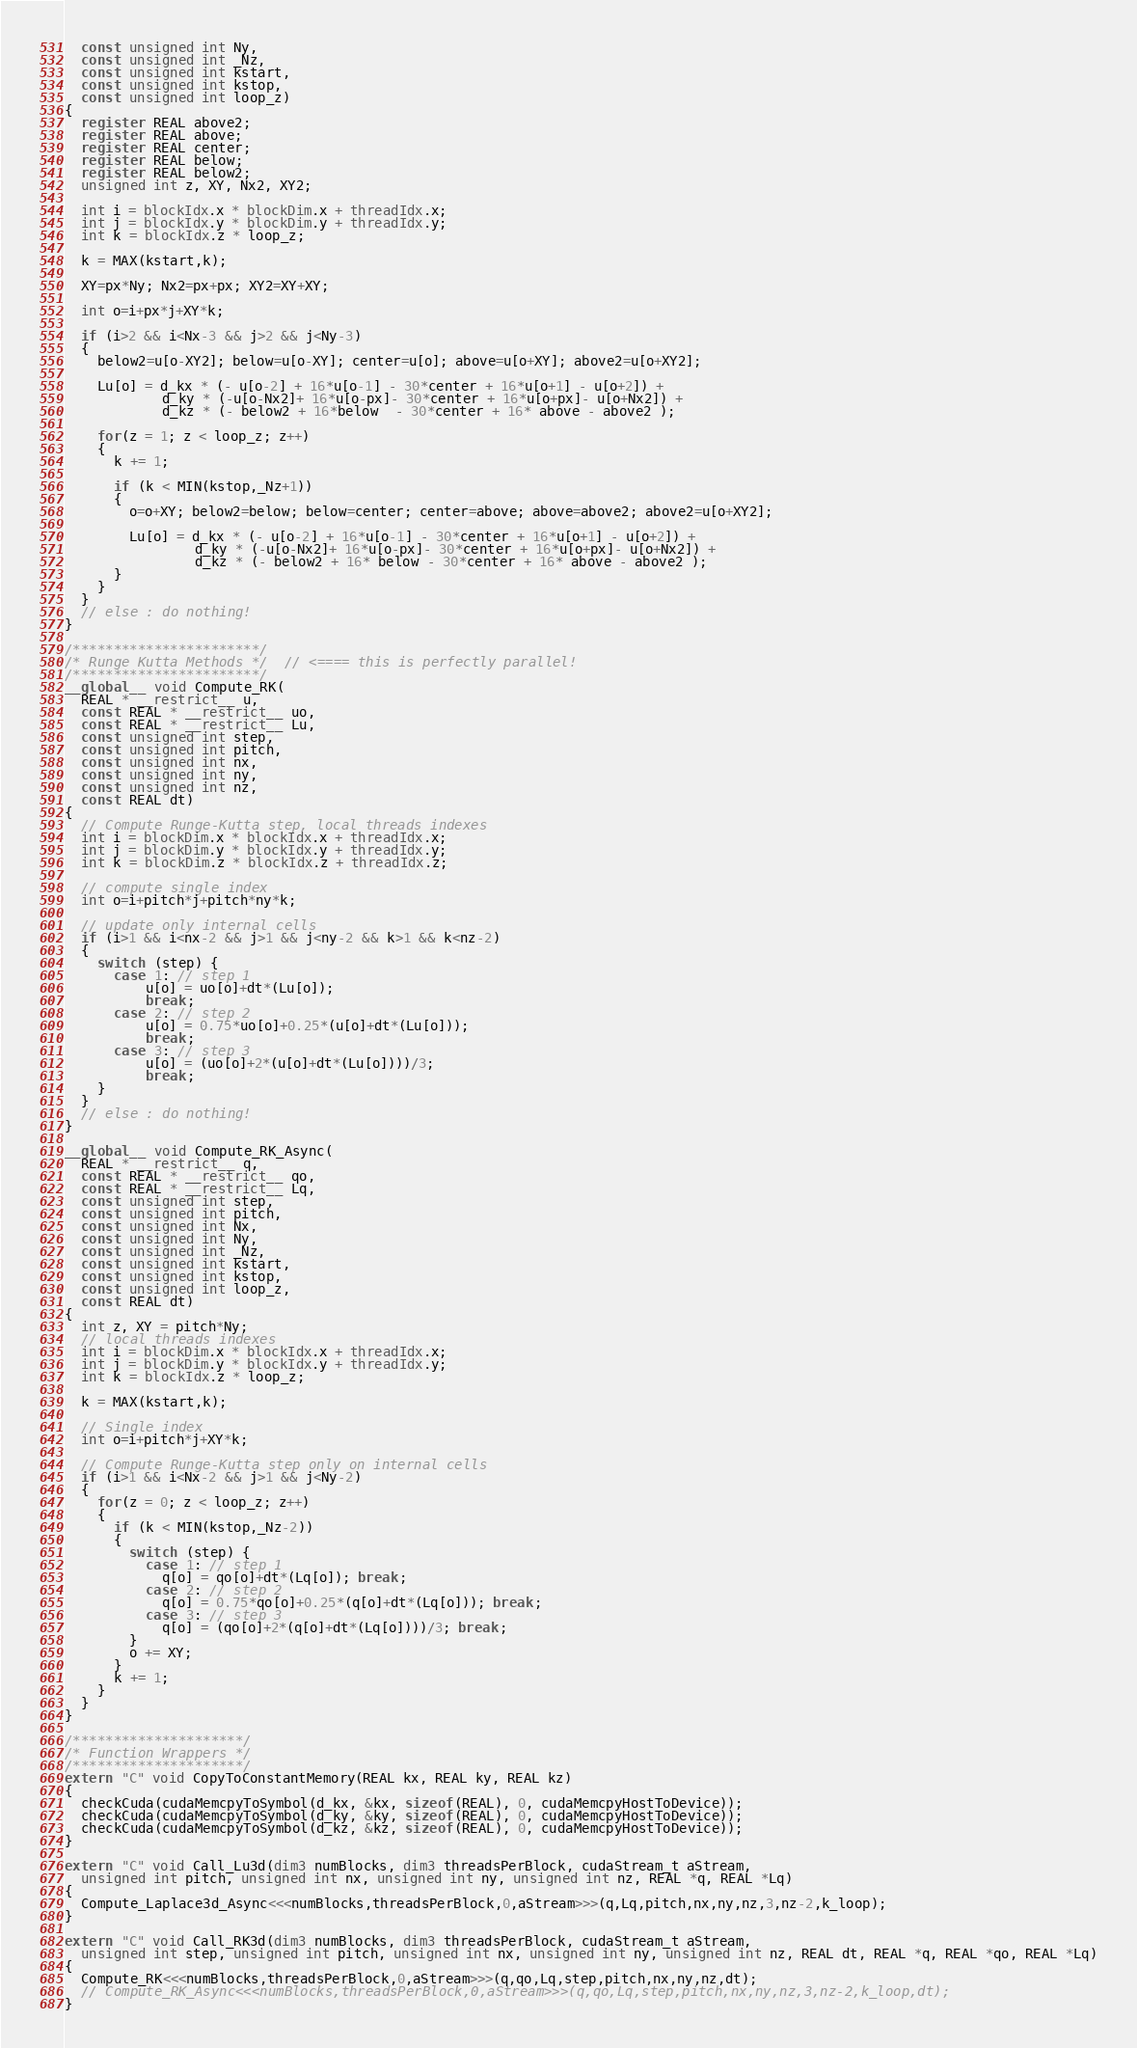Convert code to text. <code><loc_0><loc_0><loc_500><loc_500><_Cuda_>  const unsigned int Ny, 
  const unsigned int _Nz, 
  const unsigned int kstart, 
  const unsigned int kstop, 
  const unsigned int loop_z)
{
  register REAL above2;
  register REAL above;
  register REAL center;
  register REAL below;
  register REAL below2;
  unsigned int z, XY, Nx2, XY2;

  int i = blockIdx.x * blockDim.x + threadIdx.x;
  int j = blockIdx.y * blockDim.y + threadIdx.y;
  int k = blockIdx.z * loop_z;

  k = MAX(kstart,k);

  XY=px*Ny; Nx2=px+px; XY2=XY+XY; 

  int o=i+px*j+XY*k;

  if (i>2 && i<Nx-3 && j>2 && j<Ny-3)
  {
    below2=u[o-XY2]; below=u[o-XY]; center=u[o]; above=u[o+XY]; above2=u[o+XY2];

    Lu[o] = d_kx * (- u[o-2] + 16*u[o-1] - 30*center + 16*u[o+1] - u[o+2]) + 
            d_ky * (-u[o-Nx2]+ 16*u[o-px]- 30*center + 16*u[o+px]- u[o+Nx2]) +
            d_kz * (- below2 + 16*below  - 30*center + 16* above - above2 );

    for(z = 1; z < loop_z; z++)
    {
      k += 1;

      if (k < MIN(kstop,_Nz+1))
      {
        o=o+XY; below2=below; below=center; center=above; above=above2; above2=u[o+XY2];

        Lu[o] = d_kx * (- u[o-2] + 16*u[o-1] - 30*center + 16*u[o+1] - u[o+2]) +
                d_ky * (-u[o-Nx2]+ 16*u[o-px]- 30*center + 16*u[o+px]- u[o+Nx2]) +
                d_kz * (- below2 + 16* below - 30*center + 16* above - above2 );
      }
    }
  }
  // else : do nothing!
}

/***********************/
/* Runge Kutta Methods */  // <==== this is perfectly parallel!
/***********************/
__global__ void Compute_RK( 
  REAL * __restrict__ u, 
  const REAL * __restrict__ uo, 
  const REAL * __restrict__ Lu, 
  const unsigned int step, 
  const unsigned int pitch,
  const unsigned int nx, 
  const unsigned int ny, 
  const unsigned int nz, 
  const REAL dt)
{
  // Compute Runge-Kutta step, local threads indexes
  int i = blockDim.x * blockIdx.x + threadIdx.x;
  int j = blockDim.y * blockIdx.y + threadIdx.y;
  int k = blockDim.z * blockIdx.z + threadIdx.z;
    
  // compute single index
  int o=i+pitch*j+pitch*ny*k;

  // update only internal cells
  if (i>1 && i<nx-2 && j>1 && j<ny-2 && k>1 && k<nz-2)
  {
    switch (step) {
      case 1: // step 1
          u[o] = uo[o]+dt*(Lu[o]);
          break;
      case 2: // step 2
          u[o] = 0.75*uo[o]+0.25*(u[o]+dt*(Lu[o]));
          break;
      case 3: // step 3
          u[o] = (uo[o]+2*(u[o]+dt*(Lu[o])))/3;
          break;
    }
  }
  // else : do nothing!
}

__global__ void Compute_RK_Async( 
  REAL * __restrict__ q, 
  const REAL * __restrict__ qo, 
  const REAL * __restrict__ Lq, 
  const unsigned int step,
  const unsigned int pitch, 
  const unsigned int Nx, 
  const unsigned int Ny, 
  const unsigned int _Nz, 
  const unsigned int kstart, 
  const unsigned int kstop, 
  const unsigned int loop_z, 
  const REAL dt)
{
  int z, XY = pitch*Ny;
  // local threads indexes
  int i = blockDim.x * blockIdx.x + threadIdx.x;
  int j = blockDim.y * blockIdx.y + threadIdx.y;
  int k = blockIdx.z * loop_z;

  k = MAX(kstart,k);

  // Single index
  int o=i+pitch*j+XY*k;

  // Compute Runge-Kutta step only on internal cells
  if (i>1 && i<Nx-2 && j>1 && j<Ny-2)
  {
    for(z = 0; z < loop_z; z++)
    {
      if (k < MIN(kstop,_Nz-2)) 
      {
        switch (step) {
          case 1: // step 1
            q[o] = qo[o]+dt*(Lq[o]); break;
          case 2: // step 2
            q[o] = 0.75*qo[o]+0.25*(q[o]+dt*(Lq[o])); break;
          case 3: // step 3
            q[o] = (qo[o]+2*(q[o]+dt*(Lq[o])))/3; break;
        }
        o += XY;
      }
      k += 1;
    }
  }
}

/*********************/
/* Function Wrappers */
/*********************/
extern "C" void CopyToConstantMemory(REAL kx, REAL ky, REAL kz)
{
  checkCuda(cudaMemcpyToSymbol(d_kx, &kx, sizeof(REAL), 0, cudaMemcpyHostToDevice));
  checkCuda(cudaMemcpyToSymbol(d_ky, &ky, sizeof(REAL), 0, cudaMemcpyHostToDevice));
  checkCuda(cudaMemcpyToSymbol(d_kz, &kz, sizeof(REAL), 0, cudaMemcpyHostToDevice));
}

extern "C" void Call_Lu3d(dim3 numBlocks, dim3 threadsPerBlock, cudaStream_t aStream, 
  unsigned int pitch, unsigned int nx, unsigned int ny, unsigned int nz, REAL *q, REAL *Lq)
{
  Compute_Laplace3d_Async<<<numBlocks,threadsPerBlock,0,aStream>>>(q,Lq,pitch,nx,ny,nz,3,nz-2,k_loop);
}

extern "C" void Call_RK3d(dim3 numBlocks, dim3 threadsPerBlock, cudaStream_t aStream, 
  unsigned int step, unsigned int pitch, unsigned int nx, unsigned int ny, unsigned int nz, REAL dt, REAL *q, REAL *qo, REAL *Lq)
{
  Compute_RK<<<numBlocks,threadsPerBlock,0,aStream>>>(q,qo,Lq,step,pitch,nx,ny,nz,dt);
  // Compute_RK_Async<<<numBlocks,threadsPerBlock,0,aStream>>>(q,qo,Lq,step,pitch,nx,ny,nz,3,nz-2,k_loop,dt);
}
</code> 